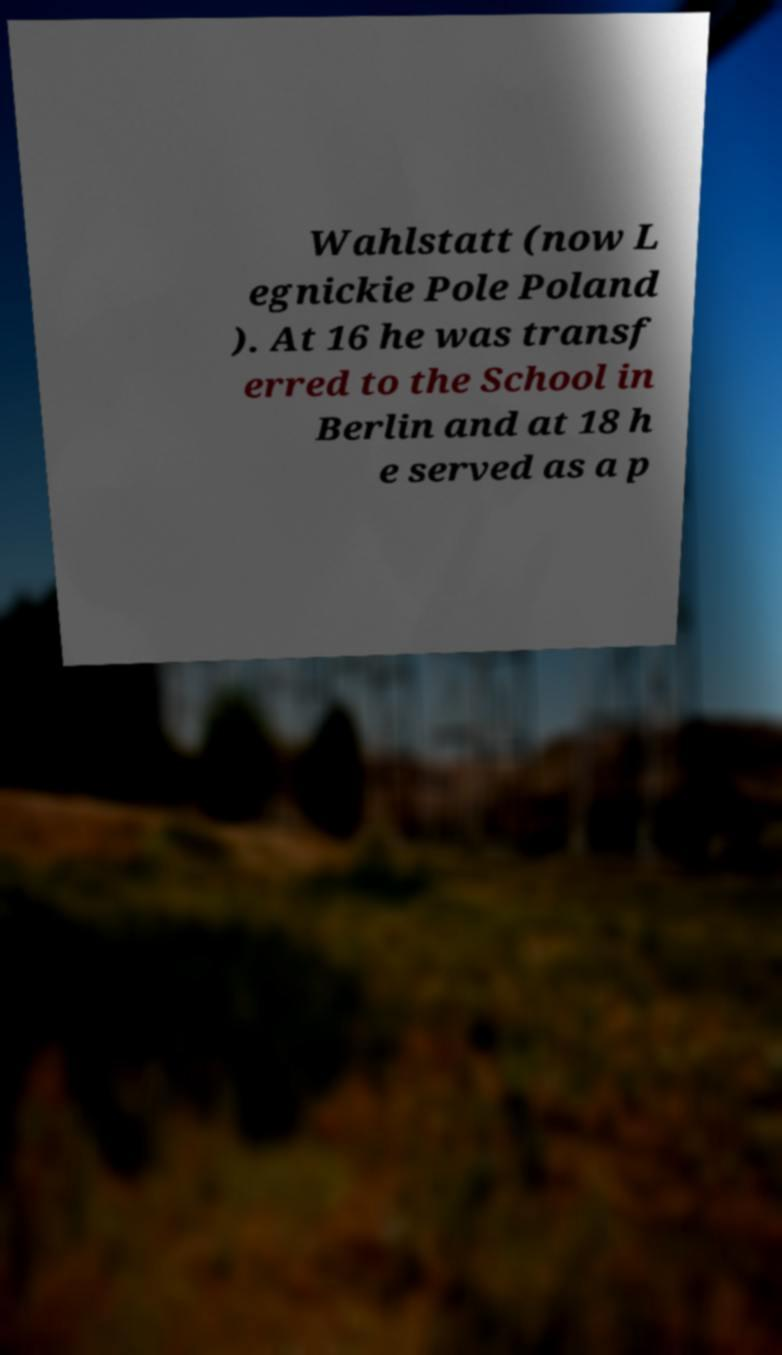Please identify and transcribe the text found in this image. Wahlstatt (now L egnickie Pole Poland ). At 16 he was transf erred to the School in Berlin and at 18 h e served as a p 